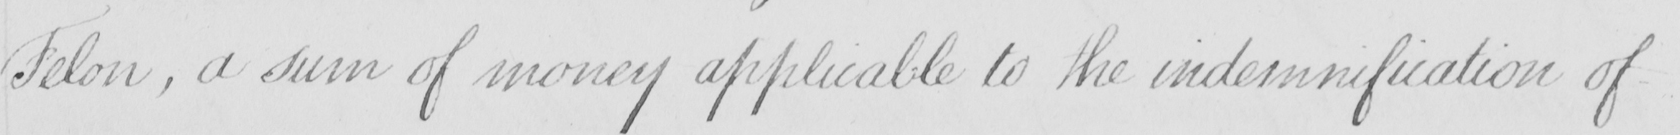Please transcribe the handwritten text in this image. Felon , a sum of money applicable to the indemnification of 